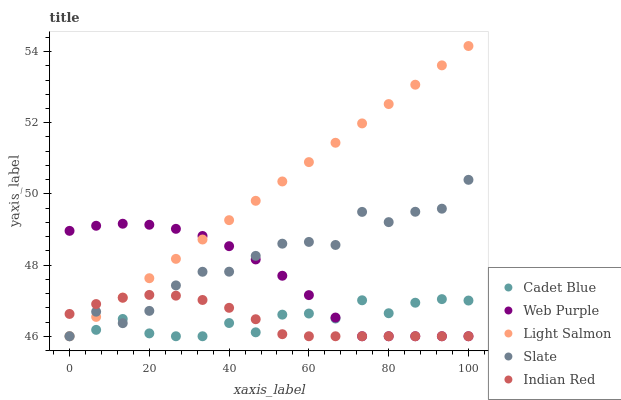Does Indian Red have the minimum area under the curve?
Answer yes or no. Yes. Does Light Salmon have the maximum area under the curve?
Answer yes or no. Yes. Does Web Purple have the minimum area under the curve?
Answer yes or no. No. Does Web Purple have the maximum area under the curve?
Answer yes or no. No. Is Light Salmon the smoothest?
Answer yes or no. Yes. Is Slate the roughest?
Answer yes or no. Yes. Is Web Purple the smoothest?
Answer yes or no. No. Is Web Purple the roughest?
Answer yes or no. No. Does Slate have the lowest value?
Answer yes or no. Yes. Does Light Salmon have the highest value?
Answer yes or no. Yes. Does Web Purple have the highest value?
Answer yes or no. No. Does Indian Red intersect Slate?
Answer yes or no. Yes. Is Indian Red less than Slate?
Answer yes or no. No. Is Indian Red greater than Slate?
Answer yes or no. No. 